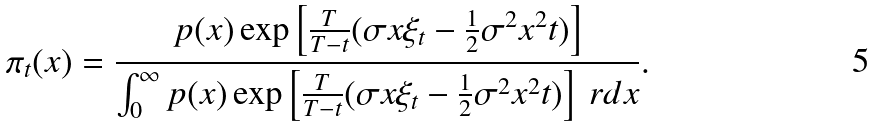<formula> <loc_0><loc_0><loc_500><loc_500>\pi _ { t } ( x ) = \frac { p ( x ) \exp \left [ \frac { T } { T - t } ( \sigma x \xi _ { t } - \frac { 1 } { 2 } \sigma ^ { 2 } x ^ { 2 } t ) \right ] } { \int ^ { \infty } _ { 0 } p ( x ) \exp \left [ \frac { T } { T - t } ( \sigma x \xi _ { t } - \frac { 1 } { 2 } \sigma ^ { 2 } x ^ { 2 } t ) \right ] \ r d x } .</formula> 